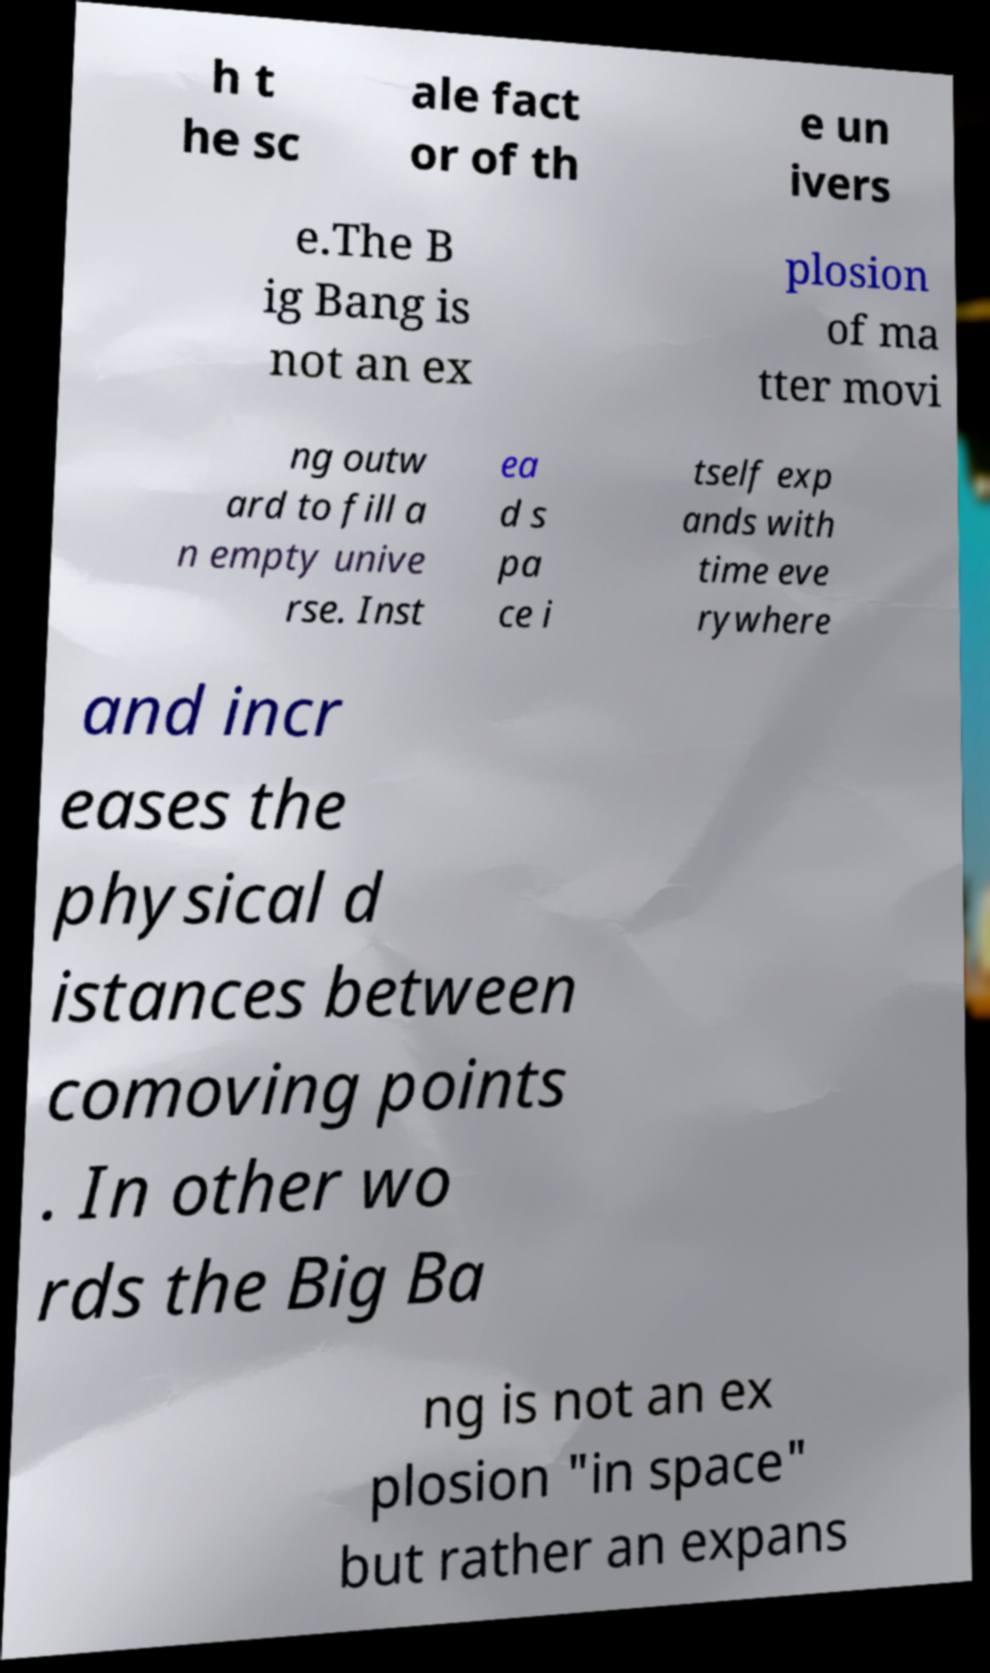What messages or text are displayed in this image? I need them in a readable, typed format. h t he sc ale fact or of th e un ivers e.The B ig Bang is not an ex plosion of ma tter movi ng outw ard to fill a n empty unive rse. Inst ea d s pa ce i tself exp ands with time eve rywhere and incr eases the physical d istances between comoving points . In other wo rds the Big Ba ng is not an ex plosion "in space" but rather an expans 